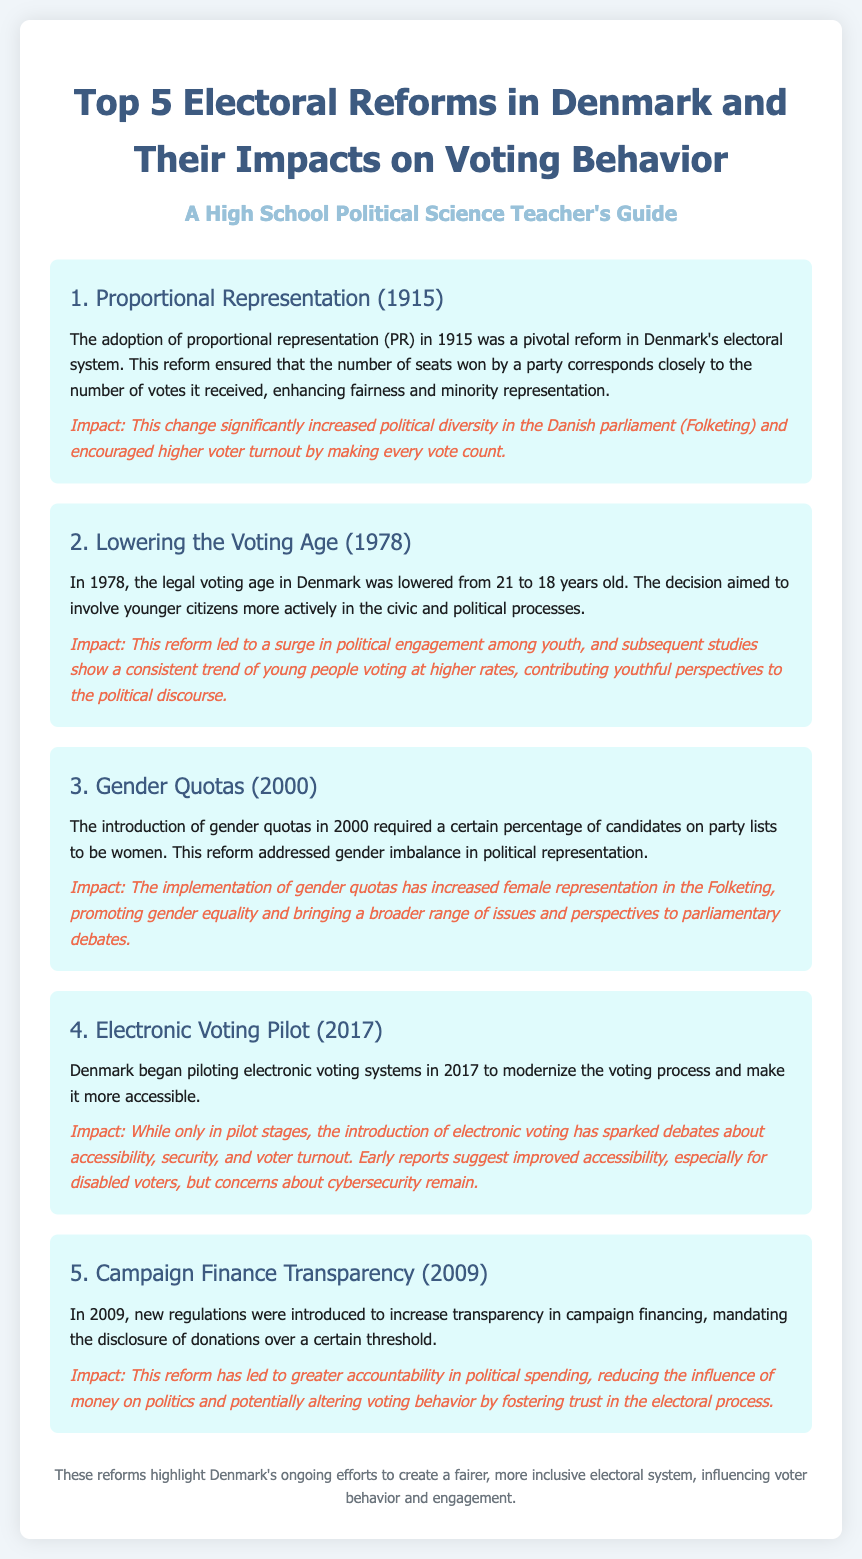What year was proportional representation adopted in Denmark? The document states that proportional representation was adopted in 1915 in Denmark.
Answer: 1915 What was the voting age changed to in 1978? According to the document, the legal voting age was lowered to 18 years old in 1978.
Answer: 18 What percentage of candidates on party lists were required to be women with the introduction of gender quotas? The document indicates a certain percentage, but it does not specify the exact figure; however, it does highlight that this measure addressed gender imbalance.
Answer: Not specified What year did Denmark begin piloting electronic voting? The document mentions that electronic voting pilot programs started in 2017.
Answer: 2017 What reform was introduced in 2009 regarding campaign finance? The document states that new regulations were implemented to increase transparency in campaign financing, specifically mandating disclosure of donations over a certain threshold.
Answer: Campaign Finance Transparency How has the adoption of proportional representation impacted voter turnout? The document notes that this change encouraged higher voter turnout by making every vote count.
Answer: Higher voter turnout What impact did lowering the voting age have on youth engagement? The document indicates that this reform led to a surge in political engagement among youth and that they vote at higher rates.
Answer: Higher rates of youth voting What is one concern regarding the electronic voting pilot? The document mentions concerns about cybersecurity as a topic of debate regarding electronic voting.
Answer: Cybersecurity concerns 